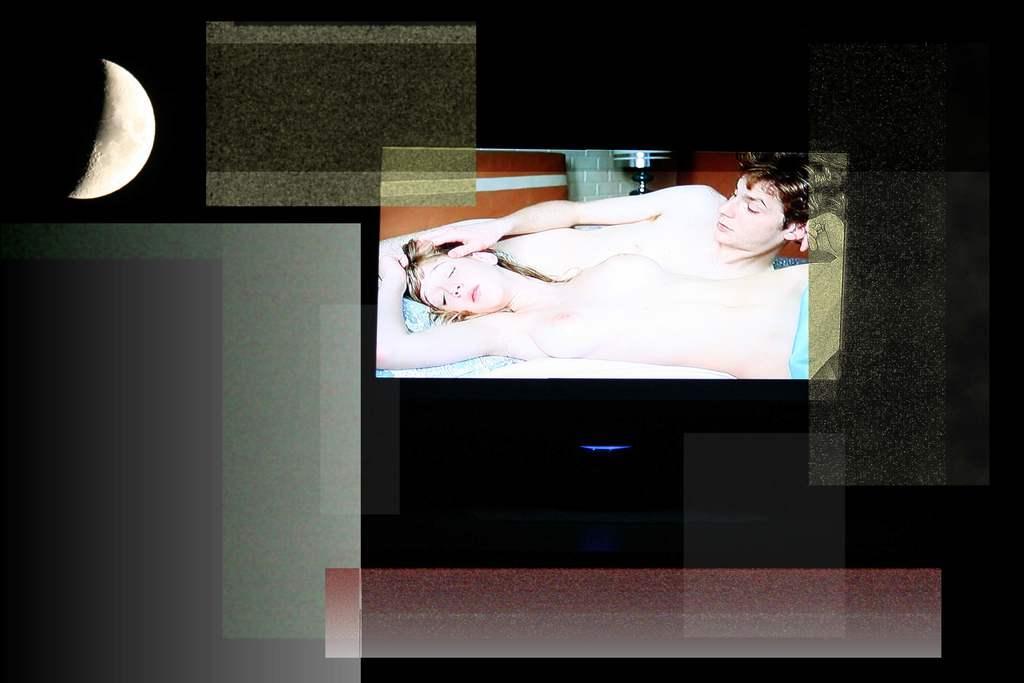In one or two sentences, can you explain what this image depicts? In this image there are two persons lying on the bed. Here there is a moon. The background is blurred. 